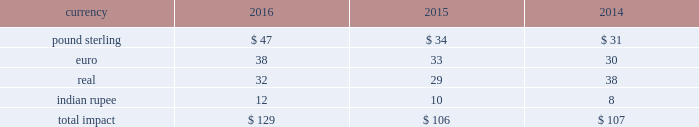Changes in the benchmark index component of the 10-year treasury yield .
The company def signated these derivatives as cash flow hedges .
On october 13 , 2015 , in conjunction with the pricing of the $ 4.5 billion senior notes , the companyr terminated these treasury lock contracts for a cash settlement payment of $ 16 million , which was recorded as a component of other comprehensive earnings and will be reclassified as an adjustment to interest expense over the ten years during which the related interest payments that were hedged will be recognized in income .
Foreign currency risk we are exposed to foreign currency risks that arise from normal business operations .
These risks include the translation of local currency balances of foreign subsidiaries , transaction gains and losses associated with intercompany loans with foreign subsidiaries and transactions denominated in currencies other than a location's functional currency .
We manage the exposure to these risks through a combination of normal operating activities and the use of foreign currency forward contracts .
Contracts are denominated in currtt encies of major industrial countries .
Our exposure to foreign currency exchange risks generally arises from our non-u.s .
Operations , to the extent they are conducted ind local currency .
Changes in foreign currency exchange rates affect translations of revenues denominated in currencies other than the u.s .
Dollar .
During the years ended december 31 , 2016 , 2015 and 2014 , we generated approximately $ 1909 million , $ 1336 million and $ 1229 million , respectively , in revenues denominated in currencies other than the u.s .
Dollar .
The major currencies to which our revenues are exposed are the brazilian real , the euro , the british pound sterling and the indian rupee .
A 10% ( 10 % ) move in average exchange rates for these currencies ( assuming a simultaneous and immediate 10% ( 10 % ) change in all of such rates for the relevant period ) would have resulted in the following increase or ( decrease ) in our reported revenues for the years ended december 31 , 2016 , 2015 and 2014 ( in millions ) : .
While our results of operations have been impacted by the effects of currency fluctuations , our international operations' revenues and expenses are generally denominated in local currency , which reduces our economic exposure to foreign exchange risk in those jurisdictions .
Revenues included $ 100 million and $ 243 million and net earnings included $ 10 million , anrr d $ 31 million , respectively , of unfavorable foreign currency impact during 2016 and 2015 resulting from a stronger u.s .
Dollar during these years compared to thet preceding year .
In 2017 , we expect continued unfavorable foreign currency impact on our operating income resulting from the continued strengthening of the u.s .
Dollar vs .
Other currencies .
Our foreign exchange risk management policy permits the use of derivative instruments , such as forward contracts and options , to reduce volatility in our results of operations and/or cash flows resulting from foreign exchange rate fluctuations .
We do not enter into foreign currency derivative instruments for trading purposes or to engage in speculative activitr y .
We do periodically enter inttt o foreign currency forward exchange contracts to hedge foreign currency exposure to intercompany loans .
As of december 31 , 2016 , the notional amount of these derivatives was approximately $ 143 million and the fair value was nominal .
These derivatives are intended to hedge the foreign exchange risks related to intercompany loans but have not been designated as hedges for accounting purposes .
We also use currency forward contracts to manage our exposure to fluctuations in costs caused by variations in indian rupee ( "inr" ) exchange rates .
As of december 31 , 2016 , the notional amount of these derivatives was approximately $ 7 million and the fair value was ll less than $ 1 million .
These inr forward contracts are designated as cash flow hedges .
The fair value of these currency forward contracts is determined using currency exchange market rates , obtained from reliable , independent , third m party banks , at the balance sheet date .
The fair value of forward contracts is subject to changes in currency exchange rates .
The company has no ineffectiveness related to its use of currency forward contracts in connection with inr cash flow hedges .
In conjunction with entering into the definitive agreement to acquire clear2pay in september 2014 , we initiated a foreign currency forward contract to purchase euros and sell u.s .
Dollars to manage the risk arising from fluctuations in exchange rates until the closing because the purchase price was stated in euros .
As this derivative did not qualify for hedge accounting , we recorded a charge of $ 16 million in other income ( expense ) , net during the third quarter of 2014 .
This forward contract was settled on october 1 , 2014. .
What was the difference in total impact between 2014 and 2015 , in millions? 
Computations: (106 - 107)
Answer: -1.0. 